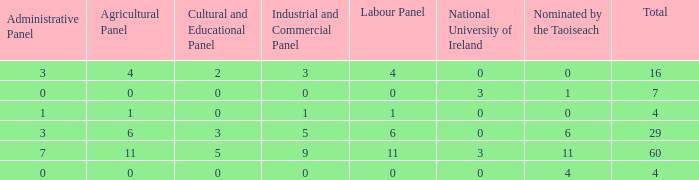What is the average administrative panel of the composition nominated by Taoiseach 0 times with a total less than 4? None. 